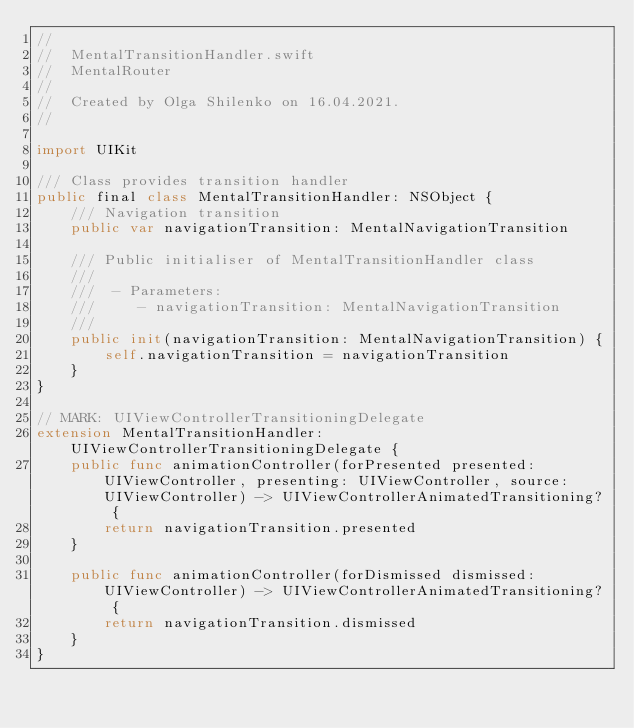<code> <loc_0><loc_0><loc_500><loc_500><_Swift_>//
//  MentalTransitionHandler.swift
//  MentalRouter
//
//  Created by Olga Shilenko on 16.04.2021.
//

import UIKit

/// Class provides transition handler
public final class MentalTransitionHandler: NSObject {
    /// Navigation transition
    public var navigationTransition: MentalNavigationTransition
    
    /// Public initialiser of MentalTransitionHandler class
    ///
    ///  - Parameters:
    ///     - navigationTransition: MentalNavigationTransition
    ///
    public init(navigationTransition: MentalNavigationTransition) {
        self.navigationTransition = navigationTransition
    }
}

// MARK: UIViewControllerTransitioningDelegate
extension MentalTransitionHandler: UIViewControllerTransitioningDelegate {
    public func animationController(forPresented presented: UIViewController, presenting: UIViewController, source: UIViewController) -> UIViewControllerAnimatedTransitioning? {
        return navigationTransition.presented
    }
    
    public func animationController(forDismissed dismissed: UIViewController) -> UIViewControllerAnimatedTransitioning? {
        return navigationTransition.dismissed
    }
}
</code> 